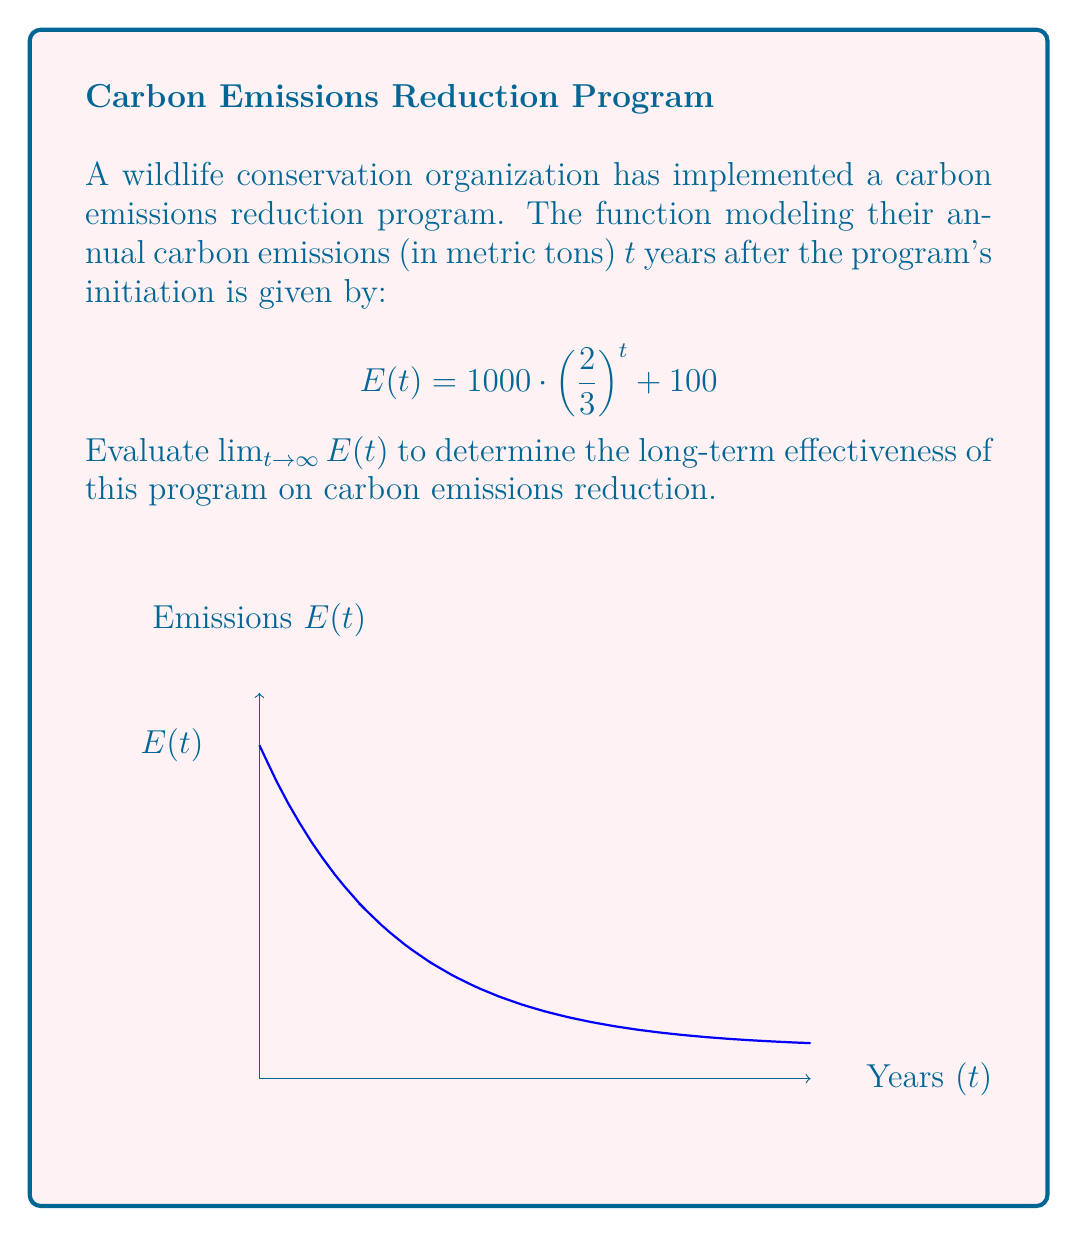Can you answer this question? To evaluate this limit, let's follow these steps:

1) First, let's examine the function:
   $$E(t) = 1000 \cdot \left(\frac{2}{3}\right)^t + 100$$

2) As $t$ approaches infinity, we need to consider what happens to each part of the function:

   a) $\left(\frac{2}{3}\right)^t$: Since $\frac{2}{3} < 1$, as $t$ increases, this term will approach 0.
   
   b) $1000 \cdot \left(\frac{2}{3}\right)^t$: This will also approach 0 as $t$ increases.
   
   c) The constant term 100 will remain unchanged.

3) Therefore, as $t$ approaches infinity:
   $$\lim_{t \to \infty} E(t) = \lim_{t \to \infty} \left[1000 \cdot \left(\frac{2}{3}\right)^t + 100\right]$$
   
4) We can separate this limit:
   $$\lim_{t \to \infty} 1000 \cdot \left(\frac{2}{3}\right)^t + \lim_{t \to \infty} 100$$

5) Simplify:
   $$1000 \cdot \lim_{t \to \infty} \left(\frac{2}{3}\right)^t + 100$$

6) As discussed, $\lim_{t \to \infty} \left(\frac{2}{3}\right)^t = 0$, so:
   $$1000 \cdot 0 + 100 = 100$$

Thus, the limit of the carbon emissions function as time approaches infinity is 100 metric tons.
Answer: 100 metric tons 